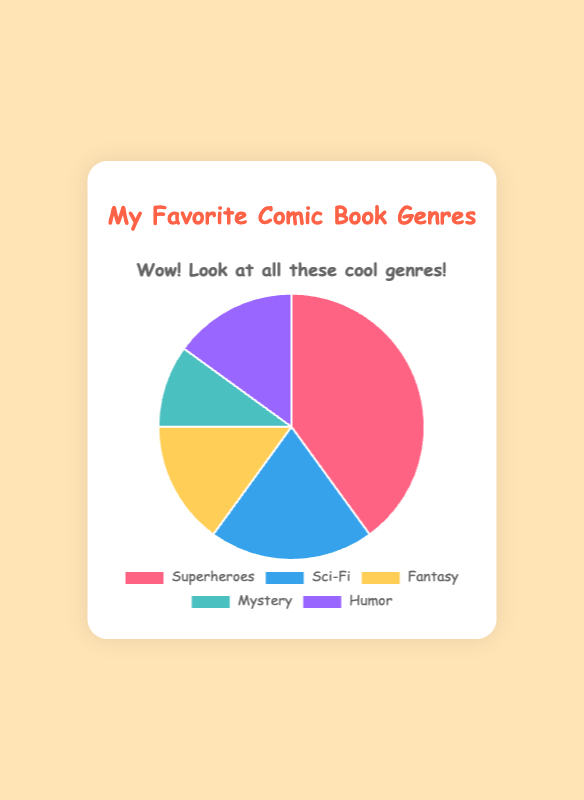What is the most popular comic book genre among kids? The most popular genre is the one with the largest slice of the pie chart. Here, "Superheroes" has the largest slice.
Answer: Superheroes How many more kids prefer Superheroes over Sci-Fi? To find the difference, subtract the Sci-Fi value from the Superheroes value: 40 - 20 = 20.
Answer: 20 Which genre has the same number of kids preferring it as Fantasy? Look for the slice that is equal in size to the Fantasy slice. Both Fantasy and Humor have 15%.
Answer: Humor What percentage of kids prefer Mystery comics? Locate the slice labeled Mystery and use the label to find its value, which is 10%.
Answer: 10% If you combine the percentages of Fantasy and Humor, will their sum be greater than the percentage of Sci-Fi? Add Fantasy and Humor values: 15 + 15 = 30. Compare this with Sci-Fi's value of 20. Since 30 > 20, the combined sum is greater.
Answer: Yes Which genre has the smallest slice in the pie chart? The smallest slice corresponds to the genre with the smallest percentage. Here, it’s Mystery with 10%.
Answer: Mystery If you combine Superheroes and Sci-Fi, what fraction of the total does this represent? Add the values of Superheroes and Sci-Fi: 40 + 20 = 60. Since the total is 100, the fraction is 60/100 or 3/5.
Answer: 3/5 How does the slice representing Fantasy compare visually to the slice for Sci-Fi? The Fantasy slice is smaller than the Sci-Fi slice, as 15% (Fantasy) is less than 20% (Sci-Fi).
Answer: Smaller What is the sum of the percentages for the least popular genres? The least popular genre percentages are Mystery (10%) and Fantasy (15%). Add 10 + 15 = 25.
Answer: 25 If you were to rank the genres based on popularity, what would the order be? Sort the genres by their size: Superheroes (40%), Sci-Fi (20%), Fantasy (15%), Humor (15%), Mystery (10%).
Answer: Superheroes, Sci-Fi, Fantasy, Humor, Mystery 